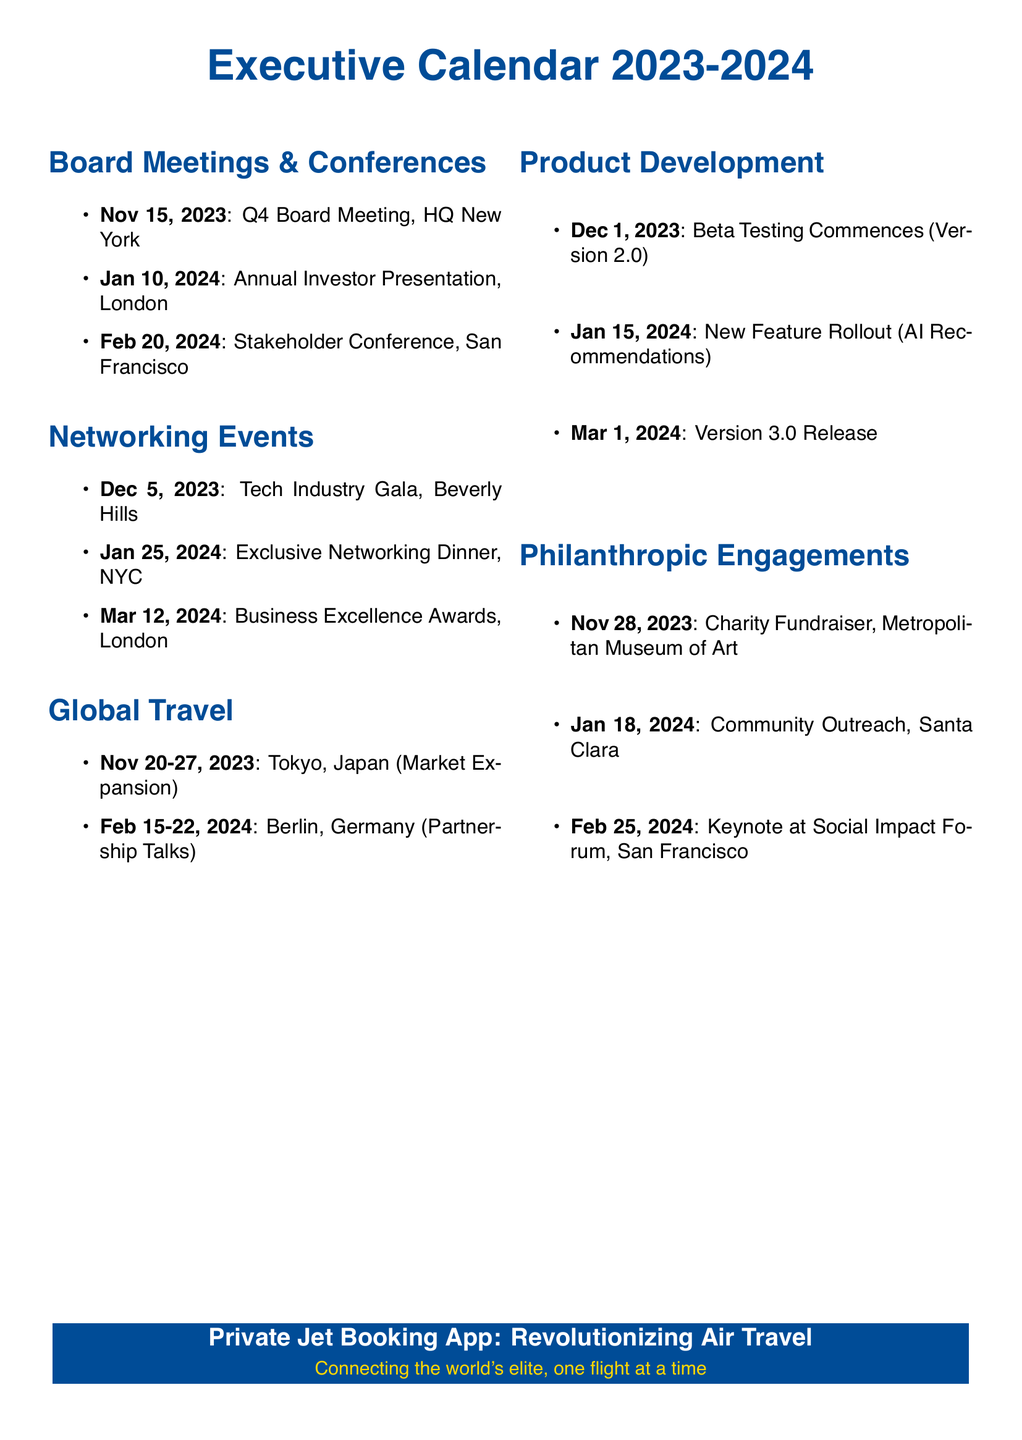What date is the Q4 Board Meeting scheduled for? The Q4 Board Meeting is listed as occurring on November 15, 2023.
Answer: November 15, 2023 What city will the Annual Investor Presentation be held in? The Annual Investor Presentation is set to take place in London according to the document.
Answer: London How many philanthropic engagements are listed? By counting the items under Philanthropic Engagements, there are three events mentioned.
Answer: 3 What is the first date of beta testing for the new app version? The document states that beta testing commences on December 1, 2023.
Answer: December 1, 2023 Which venue will host the Charity Fundraiser? The Charity Fundraiser will take place at the Metropolitan Museum of Art as indicated in the document.
Answer: Metropolitan Museum of Art What is the last listed event under Global Travel? The final event under Global Travel is scheduled for February 15-22, 2024, in Berlin, Germany.
Answer: Berlin, Germany How many Networking Events are planned prior to March 2024? There are two networking events planned before March 2024: one on December 5, 2023, and another on January 25, 2024.
Answer: 2 Which major feature release is planned for January 15, 2024? The planned feature rollout mentioned for January 15, 2024, is the AI Recommendations.
Answer: AI Recommendations What is the focus of the Tokyo trip scheduled for November 20-27, 2023? The focus of the trip to Tokyo is Market Expansion as noted in the timetable.
Answer: Market Expansion 